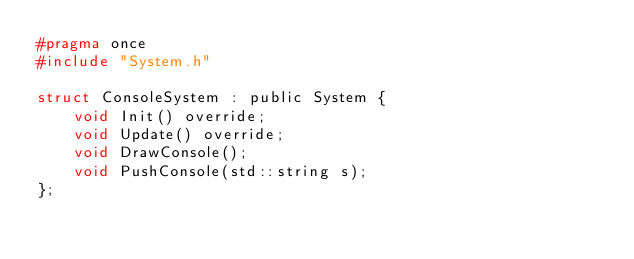Convert code to text. <code><loc_0><loc_0><loc_500><loc_500><_C_>#pragma once
#include "System.h"

struct ConsoleSystem : public System {
	void Init() override;
	void Update() override;
	void DrawConsole();
	void PushConsole(std::string s);
};</code> 